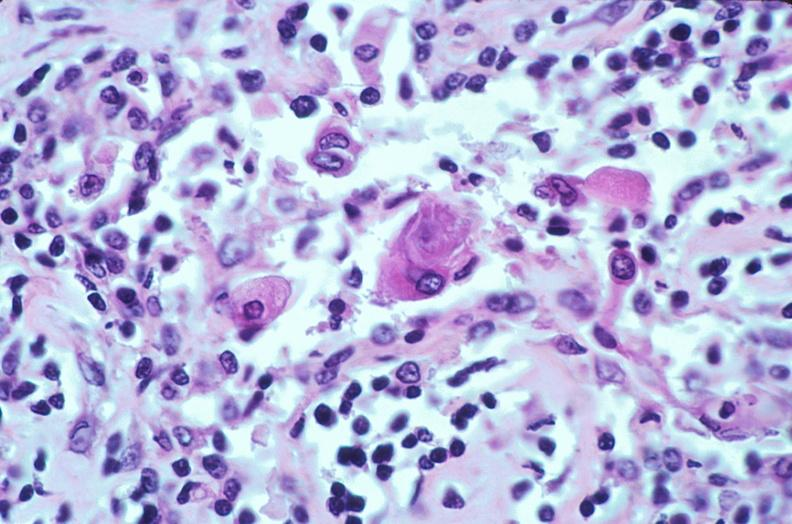does granulomata slide show lymph nodes, nodular sclerosing hodgkins disease?
Answer the question using a single word or phrase. No 